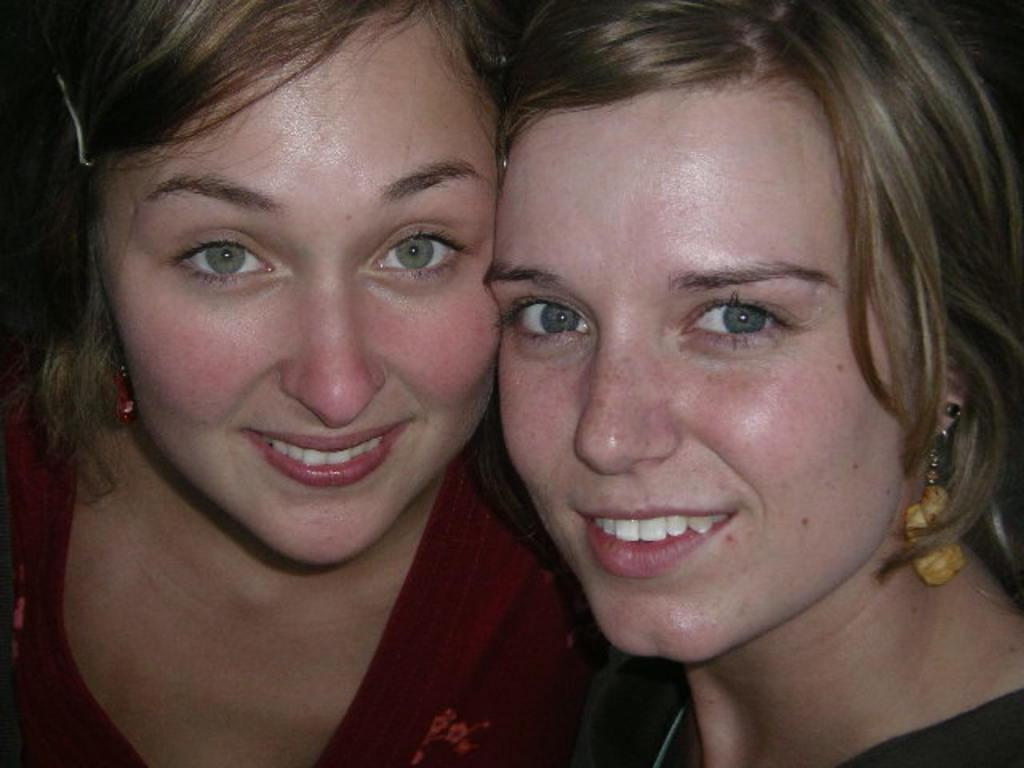How many people are in the picture? There are two women in the picture. What is the facial expression of the women in the picture? The women are smiling. What type of government is being discussed in the meeting with the manager in the image? There is no meeting or manager present in the image; it only features two women who are smiling. 